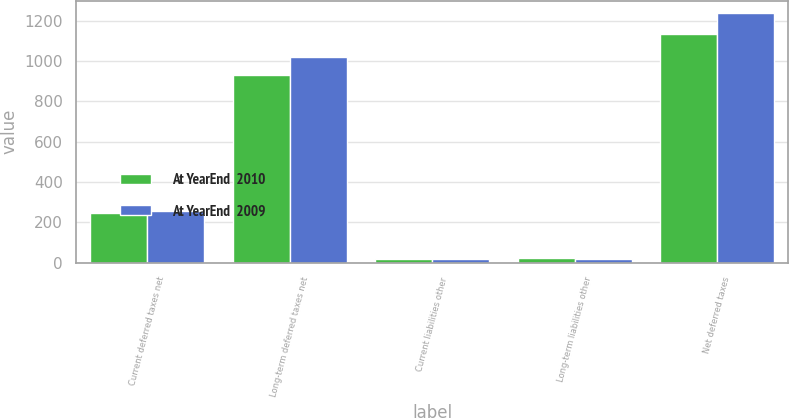Convert chart. <chart><loc_0><loc_0><loc_500><loc_500><stacked_bar_chart><ecel><fcel>Current deferred taxes net<fcel>Long-term deferred taxes net<fcel>Current liabilities other<fcel>Long-term liabilities other<fcel>Net deferred taxes<nl><fcel>At YearEnd  2010<fcel>246<fcel>932<fcel>19<fcel>23<fcel>1136<nl><fcel>At YearEnd  2009<fcel>255<fcel>1020<fcel>18<fcel>20<fcel>1237<nl></chart> 